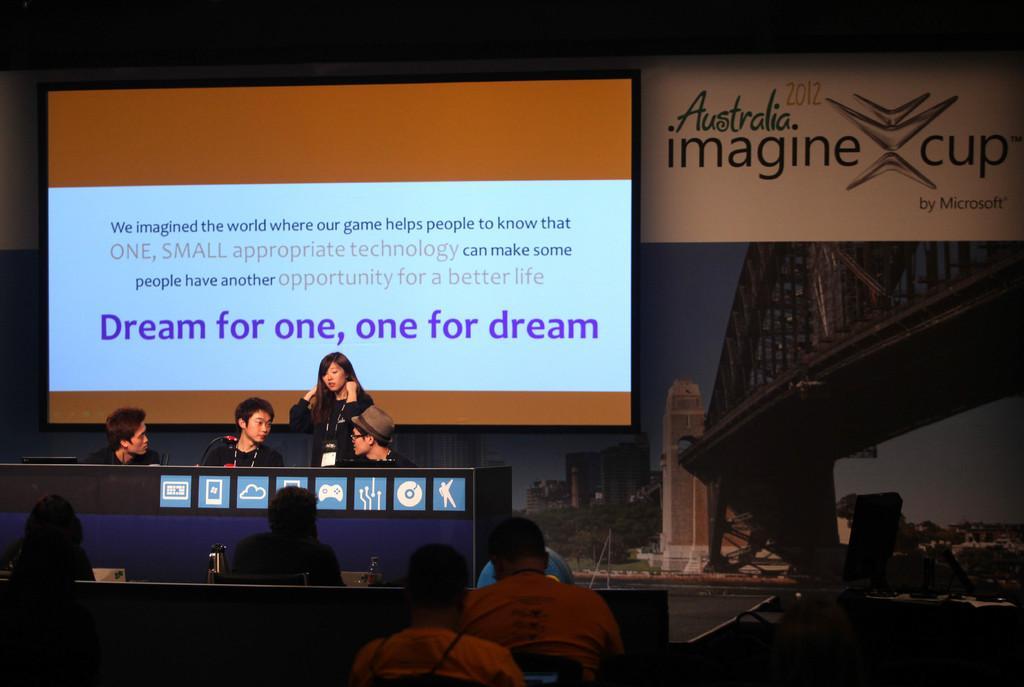How would you summarize this image in a sentence or two? In this image I can see few persons sitting on the chairs. I can see four persons on the stage. In the background I can see a projector screen. There is some text on the screen. On the right side it is looking like a banner. There is some text on it. 